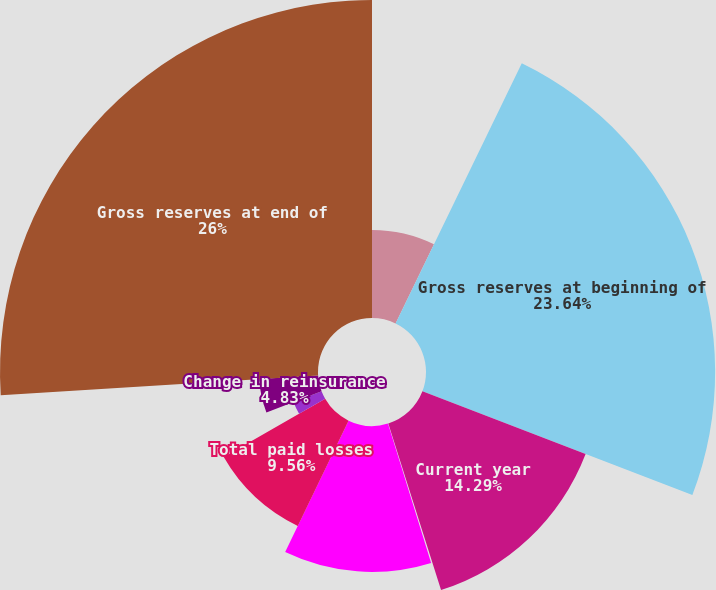Convert chart to OTSL. <chart><loc_0><loc_0><loc_500><loc_500><pie_chart><fcel>(Dollars in millions)<fcel>Gross reserves at beginning of<fcel>Current year<fcel>Prior years<fcel>Total incurred losses<fcel>Total paid losses<fcel>Foreign exchange/translation<fcel>Change in reinsurance<fcel>Gross reserves at end of<nl><fcel>7.19%<fcel>23.64%<fcel>14.29%<fcel>0.1%<fcel>11.93%<fcel>9.56%<fcel>2.46%<fcel>4.83%<fcel>26.0%<nl></chart> 